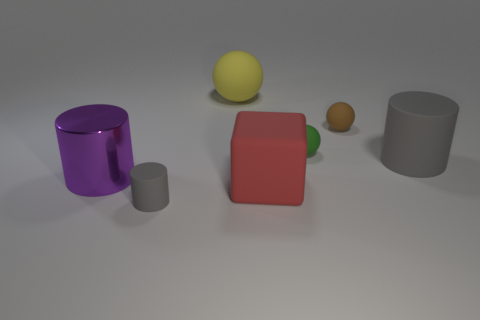Subtract all gray rubber cylinders. How many cylinders are left? 1 Subtract all purple cylinders. How many cylinders are left? 2 Add 3 small green objects. How many objects exist? 10 Subtract all blue balls. Subtract all yellow blocks. How many balls are left? 3 Subtract all balls. How many objects are left? 4 Subtract all red spheres. How many gray cylinders are left? 2 Subtract all cyan blocks. Subtract all yellow spheres. How many objects are left? 6 Add 7 tiny rubber spheres. How many tiny rubber spheres are left? 9 Add 5 small gray matte blocks. How many small gray matte blocks exist? 5 Subtract 1 brown spheres. How many objects are left? 6 